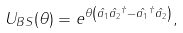<formula> <loc_0><loc_0><loc_500><loc_500>U _ { B S } ( \theta ) = e ^ { \theta \left ( \hat { a _ { 1 } } \hat { a _ { 2 } } ^ { \dagger } - \hat { a _ { 1 } } ^ { \dagger } \hat { a _ { 2 } } \right ) } ,</formula> 